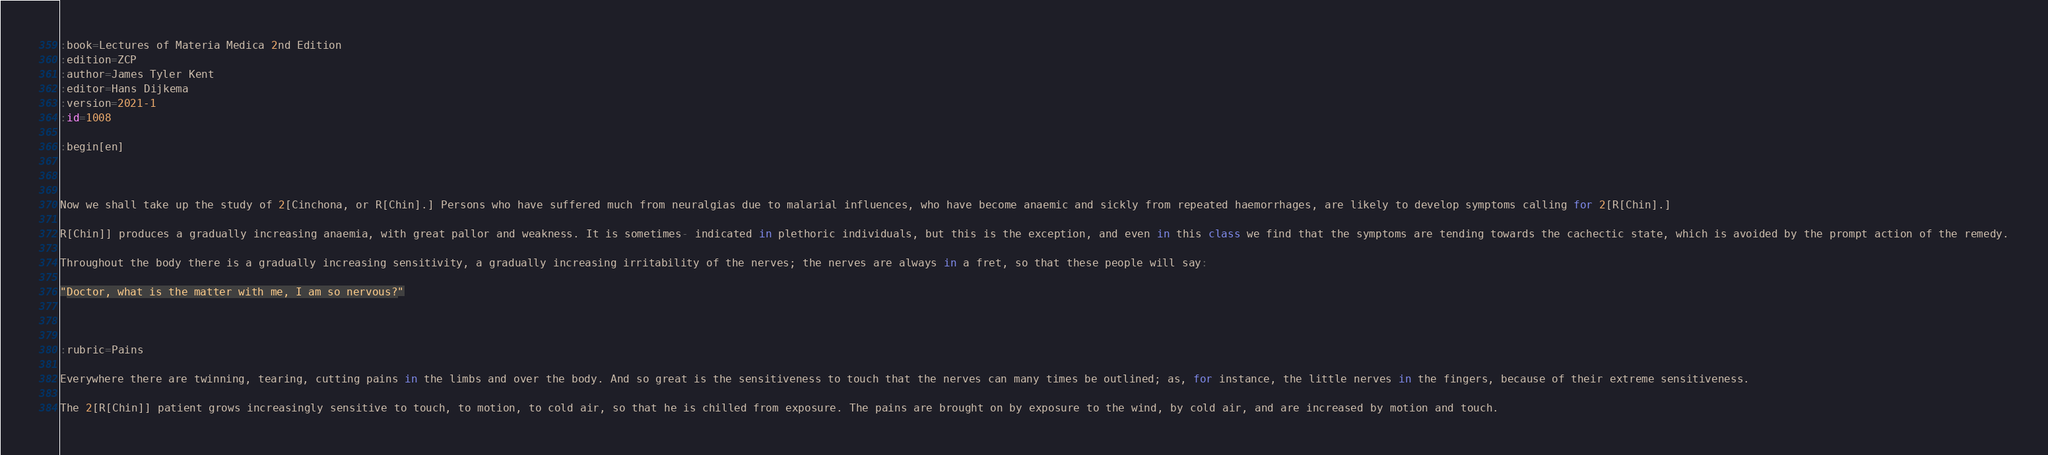<code> <loc_0><loc_0><loc_500><loc_500><_ObjectiveC_>:book=Lectures of Materia Medica 2nd Edition
:edition=ZCP
:author=James Tyler Kent
:editor=Hans Dijkema
:version=2021-1
:id=1008

:begin[en]



Now we shall take up the study of 2[Cinchona, or R[Chin].] Persons who have suffered much from neuralgias due to malarial influences, who have become anaemic and sickly from repeated haemorrhages, are likely to develop symptoms calling for 2[R[Chin].]

R[Chin]] produces a gradually increasing anaemia, with great pallor and weakness. It is sometimes- indicated in plethoric individuals, but this is the exception, and even in this class we find that the symptoms are tending towards the cachectic state, which is avoided by the prompt action of the remedy.

Throughout the body there is a gradually increasing sensitivity, a gradually increasing irritability of the nerves; the nerves are always in a fret, so that these people will say:

"Doctor, what is the matter with me, I am so nervous?"



:rubric=Pains

Everywhere there are twinning, tearing, cutting pains in the limbs and over the body. And so great is the sensitiveness to touch that the nerves can many times be outlined; as, for instance, the little nerves in the fingers, because of their extreme sensitiveness.

The 2[R[Chin]] patient grows increasingly sensitive to touch, to motion, to cold air, so that he is chilled from exposure. The pains are brought on by exposure to the wind, by cold air, and are increased by motion and touch.
</code> 